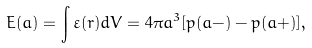Convert formula to latex. <formula><loc_0><loc_0><loc_500><loc_500>E ( a ) = \int { \varepsilon ( r ) d V } = 4 \pi a ^ { 3 } [ p ( a - ) - p ( a + ) ] ,</formula> 